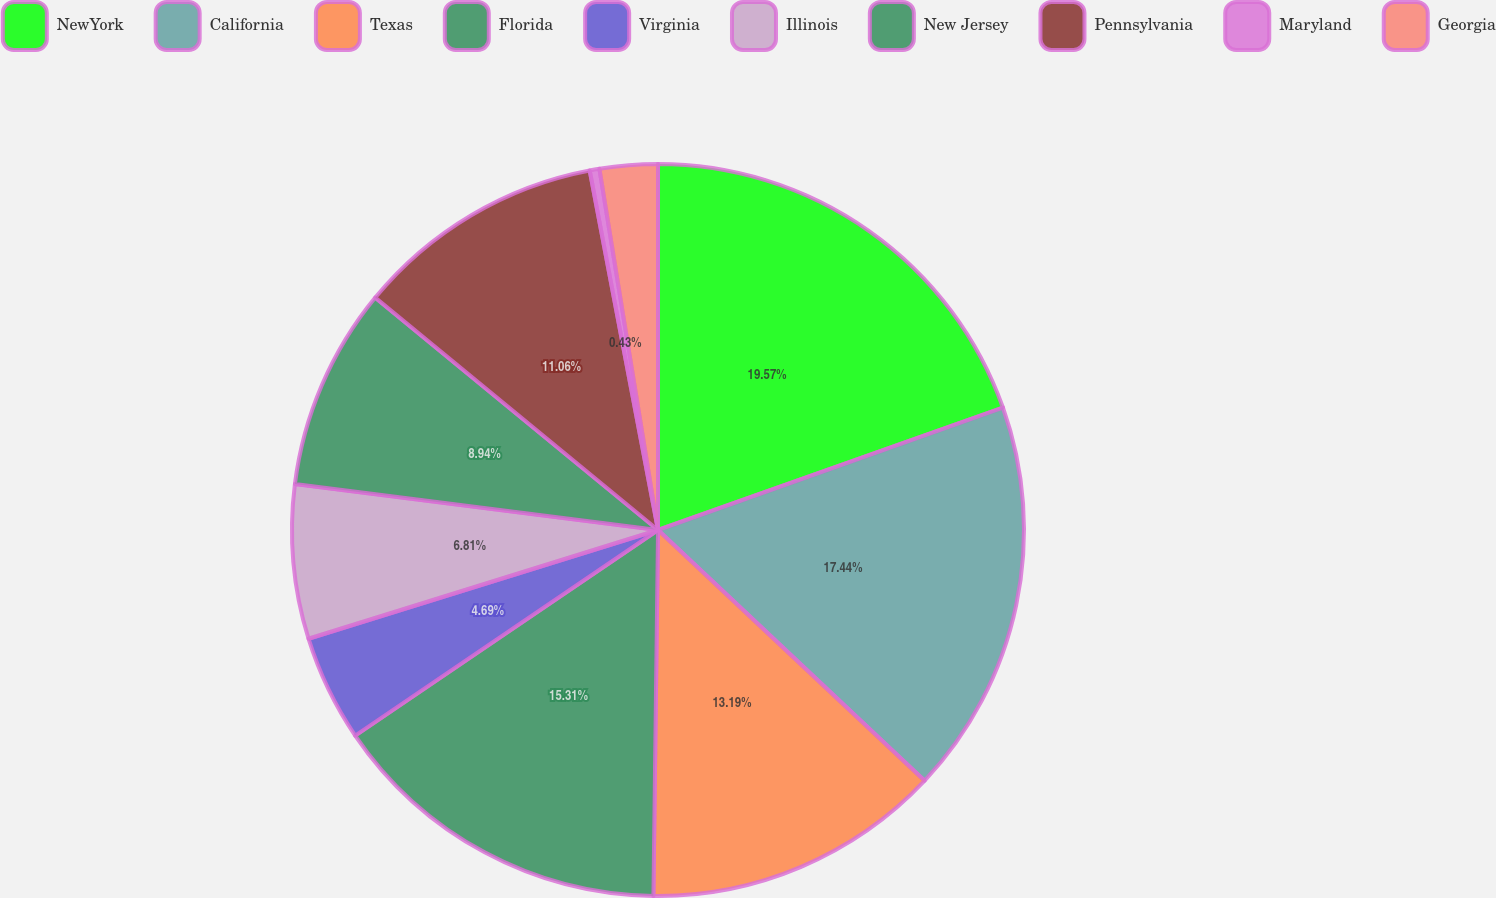Convert chart to OTSL. <chart><loc_0><loc_0><loc_500><loc_500><pie_chart><fcel>NewYork<fcel>California<fcel>Texas<fcel>Florida<fcel>Virginia<fcel>Illinois<fcel>New Jersey<fcel>Pennsylvania<fcel>Maryland<fcel>Georgia<nl><fcel>19.57%<fcel>17.44%<fcel>13.19%<fcel>15.31%<fcel>4.69%<fcel>6.81%<fcel>8.94%<fcel>11.06%<fcel>0.43%<fcel>2.56%<nl></chart> 